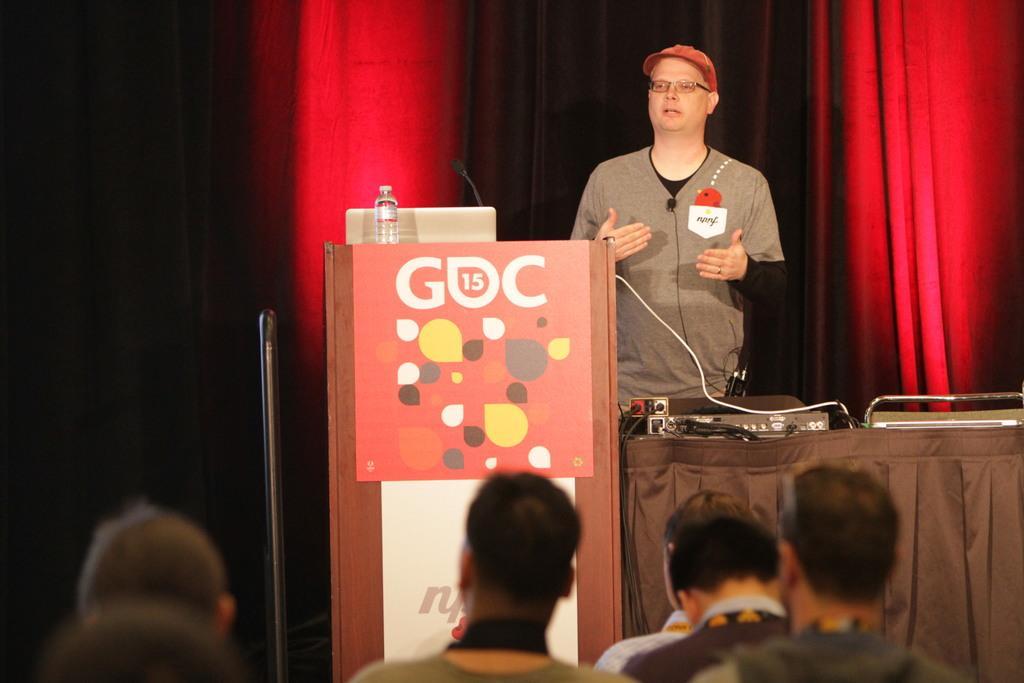Could you give a brief overview of what you see in this image? In this picture I can see a man standing and speaking and I can see a laptop, bottle and a microphone on the podium and I can see few electronic items on the the table and I can see few people seated and a red color cloth in the background. 